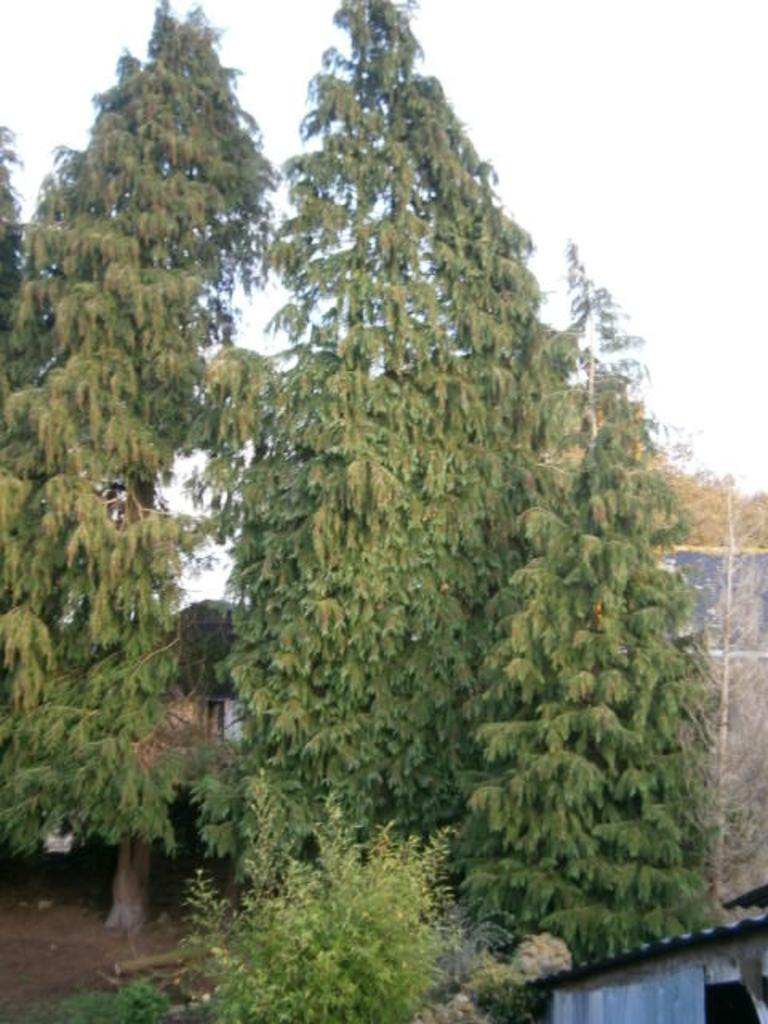What can be seen in the sky in the image? The sky is visible in the image. What type of vegetation is present in the image? There are trees in the image. What type of structure can be seen in the image? There is a shed in the image. What is the surface on which the trees and shed are located? The ground is visible in the image. What type of arithmetic problem is being solved by the trees in the image? There is no arithmetic problem being solved by the trees in the image; they are simply trees. What disease is affecting the shed in the image? There is no disease affecting the shed in the image; it is a structure. 